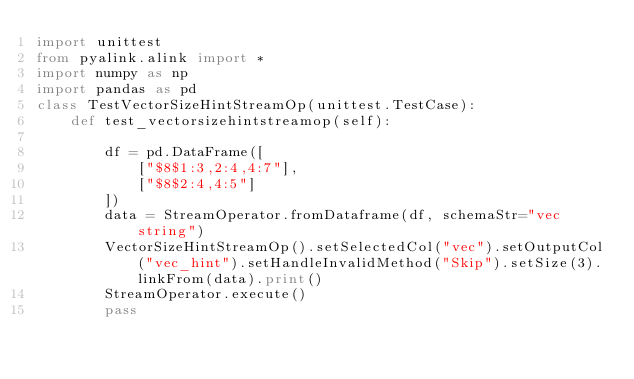Convert code to text. <code><loc_0><loc_0><loc_500><loc_500><_Python_>import unittest
from pyalink.alink import *
import numpy as np
import pandas as pd
class TestVectorSizeHintStreamOp(unittest.TestCase):
    def test_vectorsizehintstreamop(self):

        df = pd.DataFrame([
            ["$8$1:3,2:4,4:7"],
            ["$8$2:4,4:5"]
        ])
        data = StreamOperator.fromDataframe(df, schemaStr="vec string")
        VectorSizeHintStreamOp().setSelectedCol("vec").setOutputCol("vec_hint").setHandleInvalidMethod("Skip").setSize(3).linkFrom(data).print()
        StreamOperator.execute()
        pass</code> 